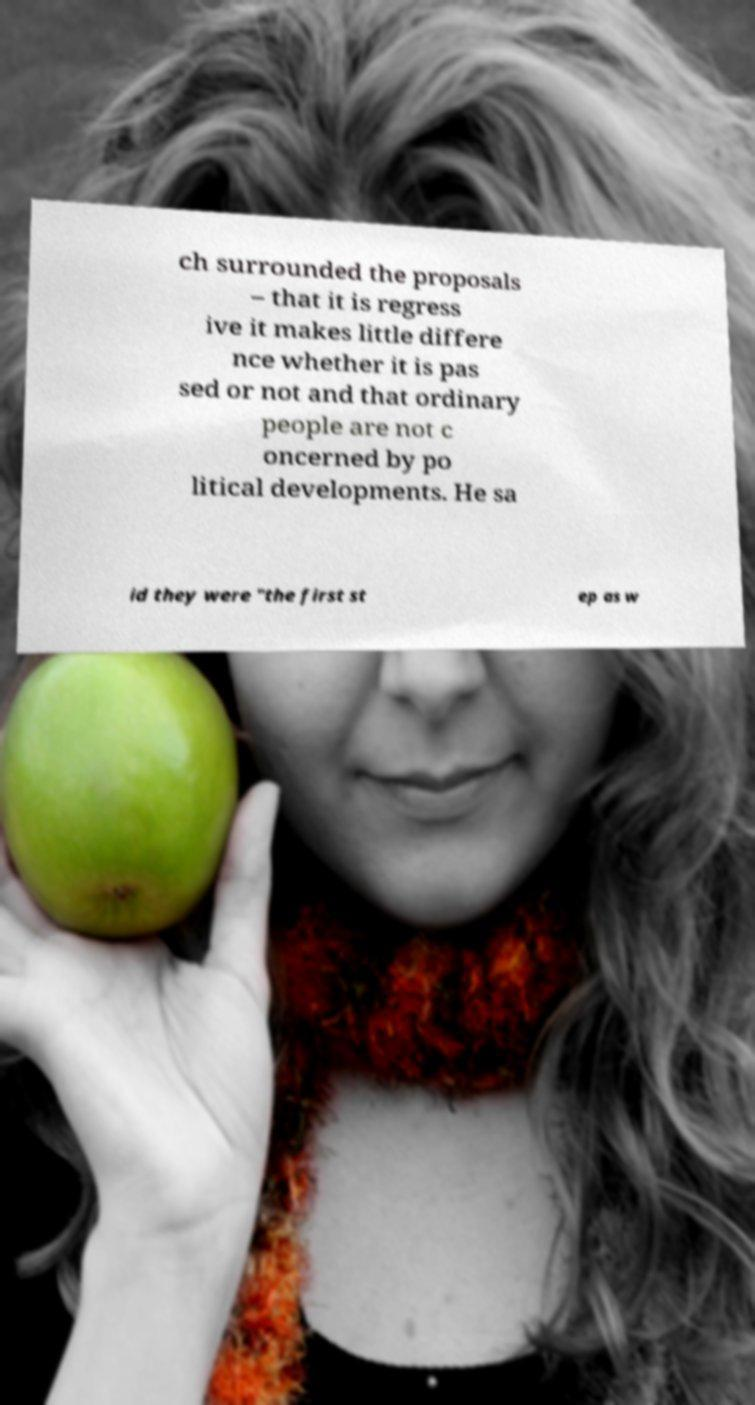Can you accurately transcribe the text from the provided image for me? ch surrounded the proposals – that it is regress ive it makes little differe nce whether it is pas sed or not and that ordinary people are not c oncerned by po litical developments. He sa id they were "the first st ep as w 